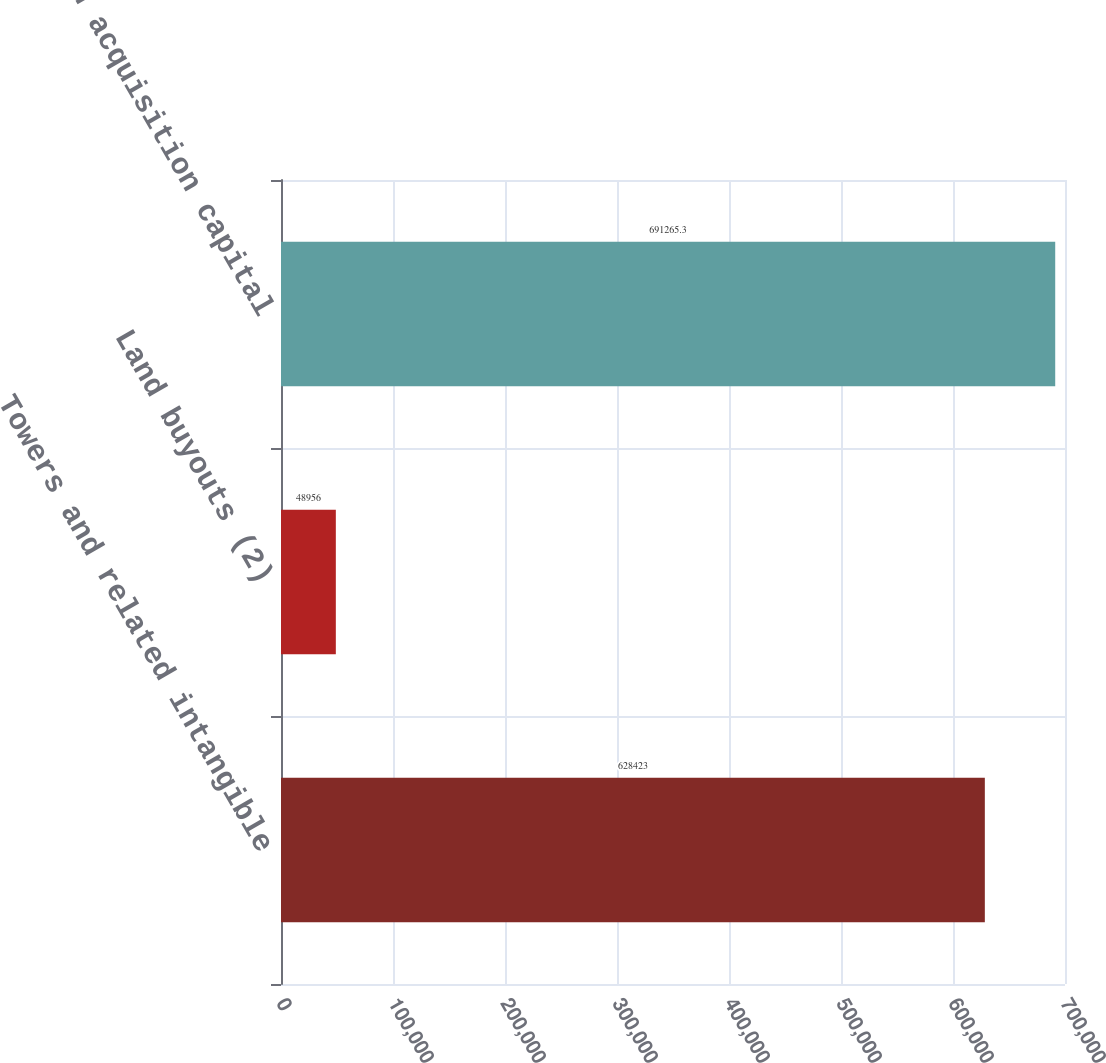<chart> <loc_0><loc_0><loc_500><loc_500><bar_chart><fcel>Towers and related intangible<fcel>Land buyouts (2)<fcel>Total cash acquisition capital<nl><fcel>628423<fcel>48956<fcel>691265<nl></chart> 